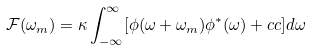<formula> <loc_0><loc_0><loc_500><loc_500>\mathcal { F } ( \omega _ { m } ) = \kappa \int _ { - \infty } ^ { \infty } [ \phi ( \omega + \omega _ { m } ) \phi ^ { * } ( \omega ) + c c ] d \omega</formula> 